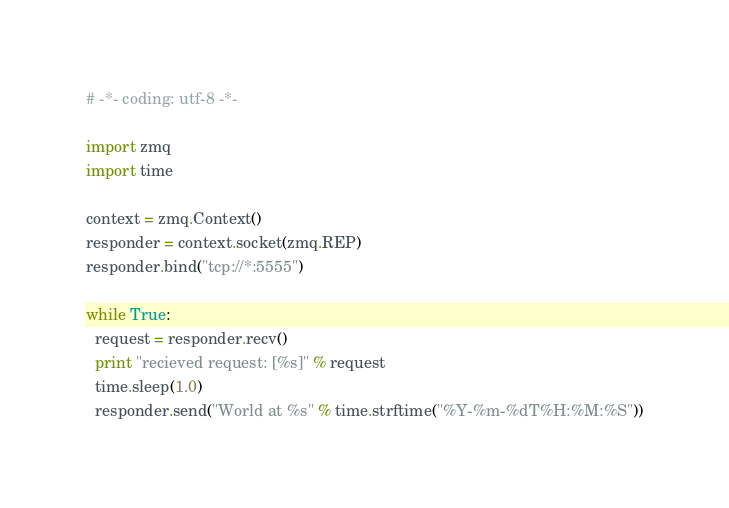<code> <loc_0><loc_0><loc_500><loc_500><_Python_># -*- coding: utf-8 -*-

import zmq
import time

context = zmq.Context()
responder = context.socket(zmq.REP)
responder.bind("tcp://*:5555")

while True:
  request = responder.recv()
  print "recieved request: [%s]" % request
  time.sleep(1.0)
  responder.send("World at %s" % time.strftime("%Y-%m-%dT%H:%M:%S"))
</code> 